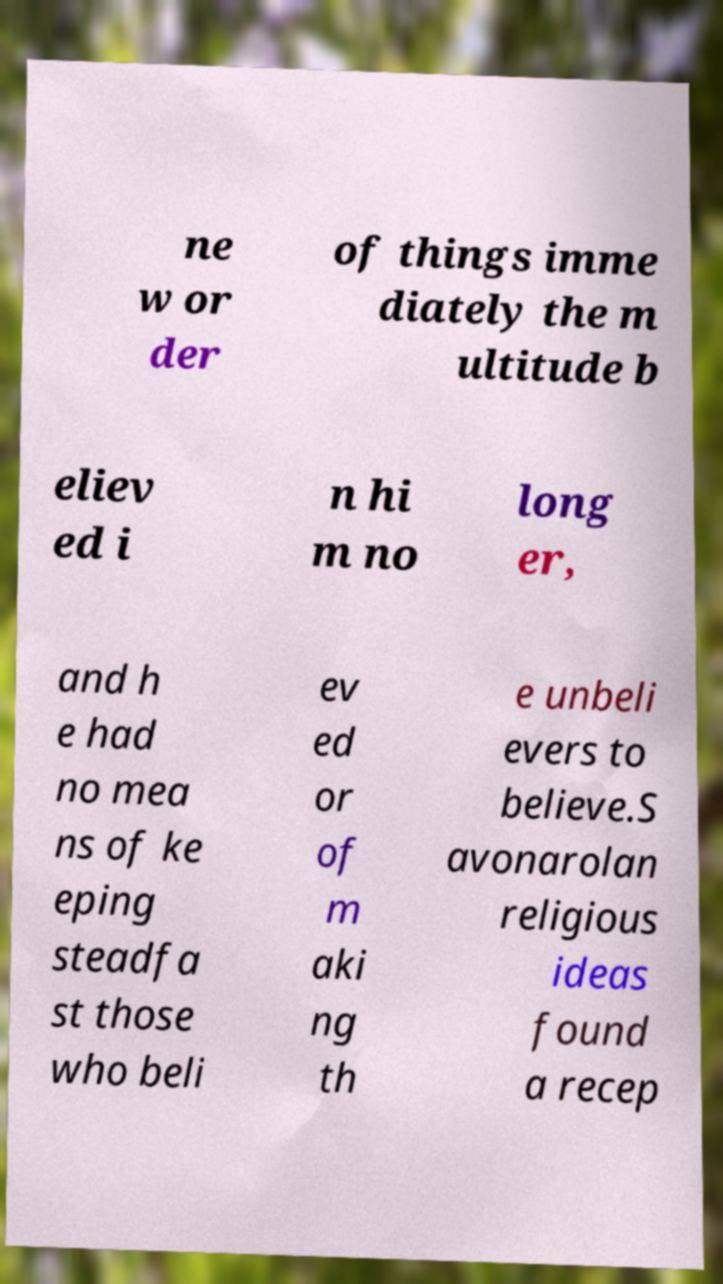Can you read and provide the text displayed in the image?This photo seems to have some interesting text. Can you extract and type it out for me? ne w or der of things imme diately the m ultitude b eliev ed i n hi m no long er, and h e had no mea ns of ke eping steadfa st those who beli ev ed or of m aki ng th e unbeli evers to believe.S avonarolan religious ideas found a recep 